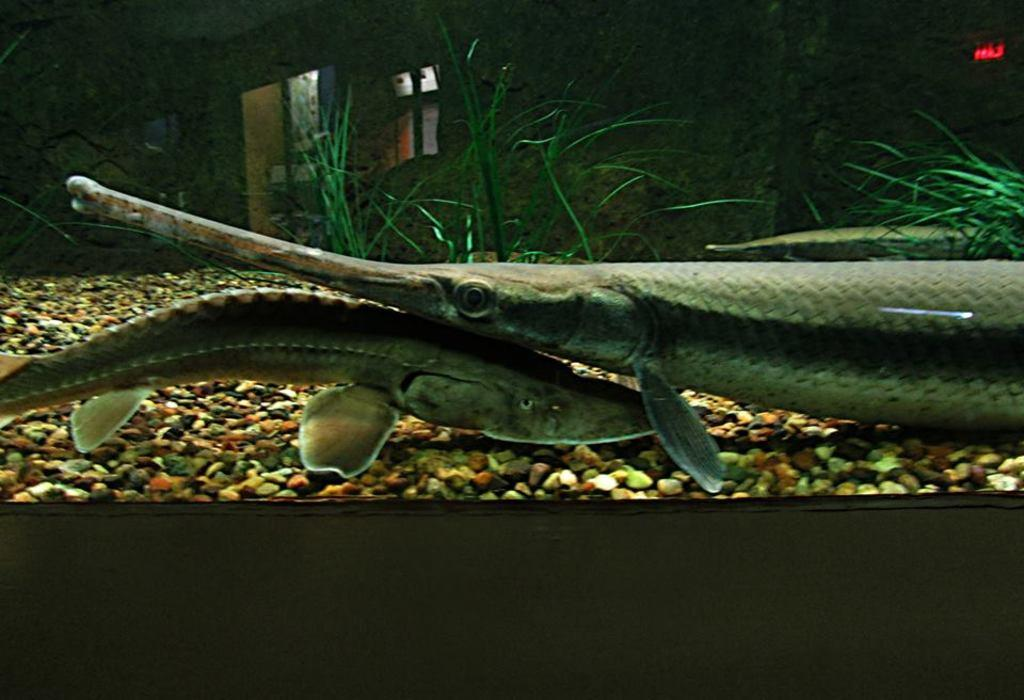What type of animals can be seen in the image? There are fishes in the image. What other objects are present in the image? There are stones and grass in the image. Where are these elements located? The elements mentioned are contained within an aquarium. What type of playground equipment can be seen in the image? There is no playground equipment present in the image; it features an aquarium with fishes, stones, and grass. How much value does the brother place on the items in the image? There is no brother mentioned in the image, and therefore no value can be attributed to their opinion on the items. 